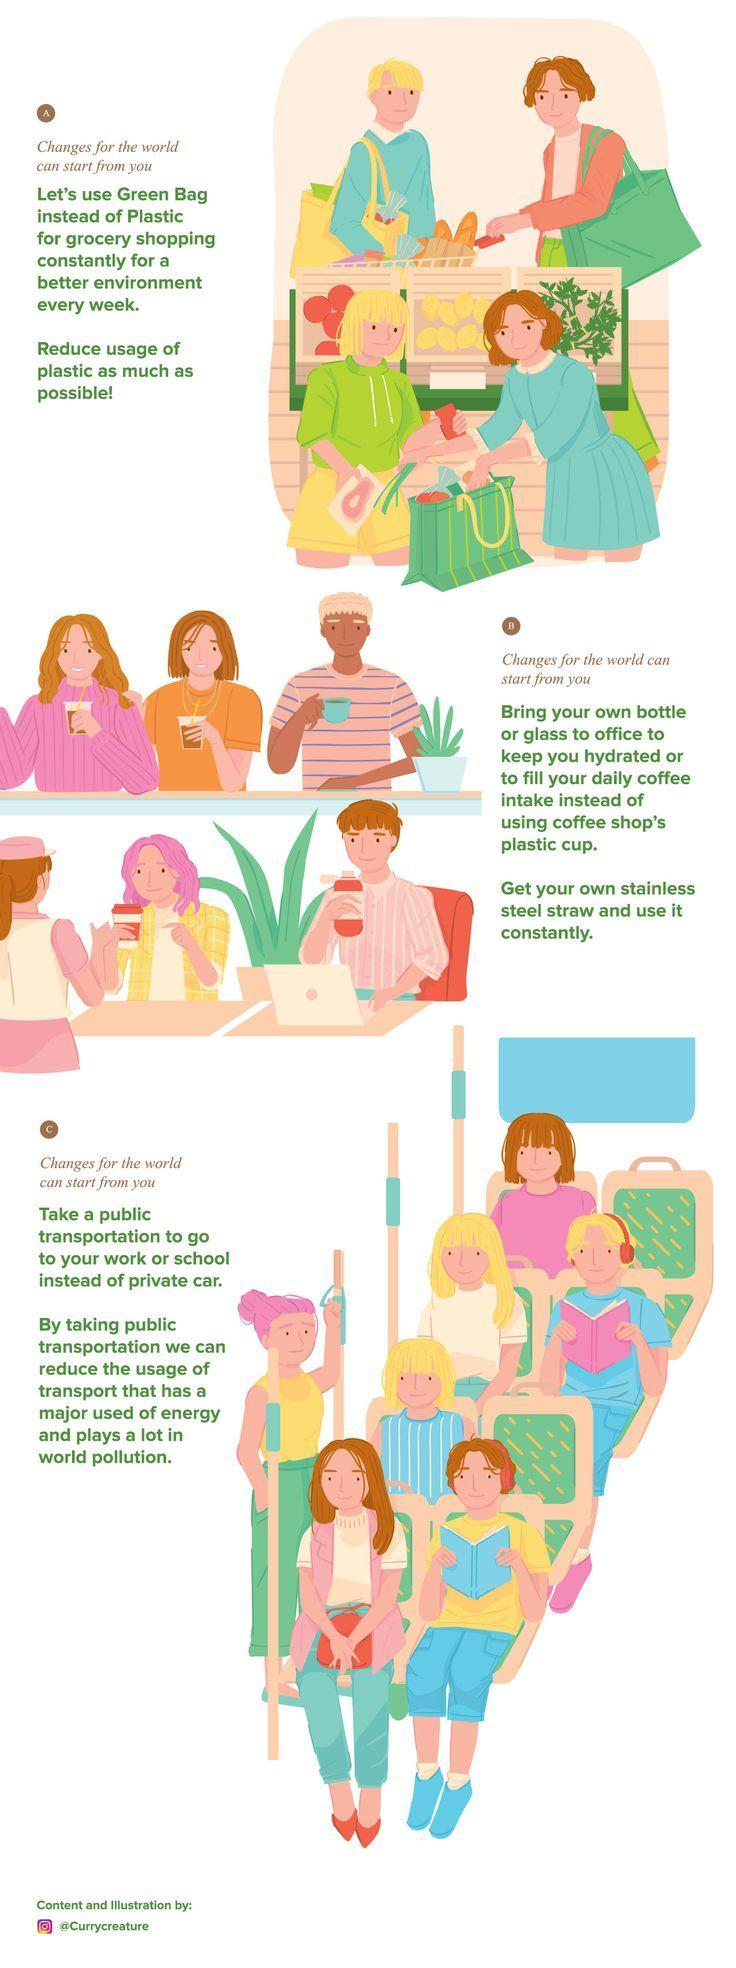How many people are standing inside the bus?
Answer the question with a short phrase. 2 How many people are sitting inside the bus? 6 